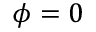Convert formula to latex. <formula><loc_0><loc_0><loc_500><loc_500>\phi = 0</formula> 